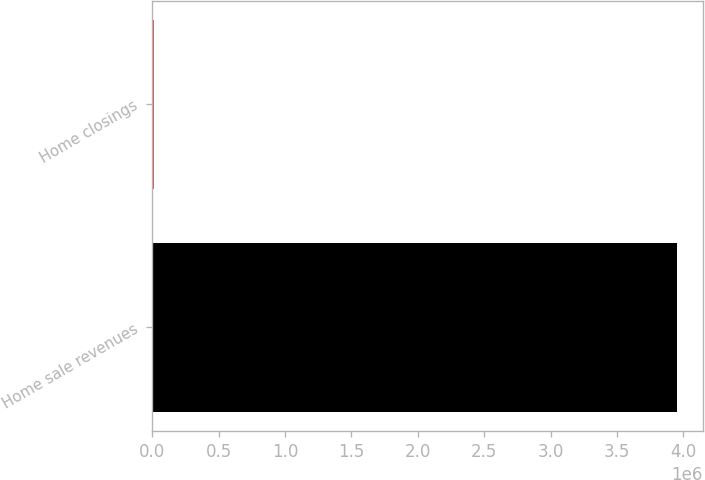<chart> <loc_0><loc_0><loc_500><loc_500><bar_chart><fcel>Home sale revenues<fcel>Home closings<nl><fcel>3.95074e+06<fcel>15275<nl></chart> 